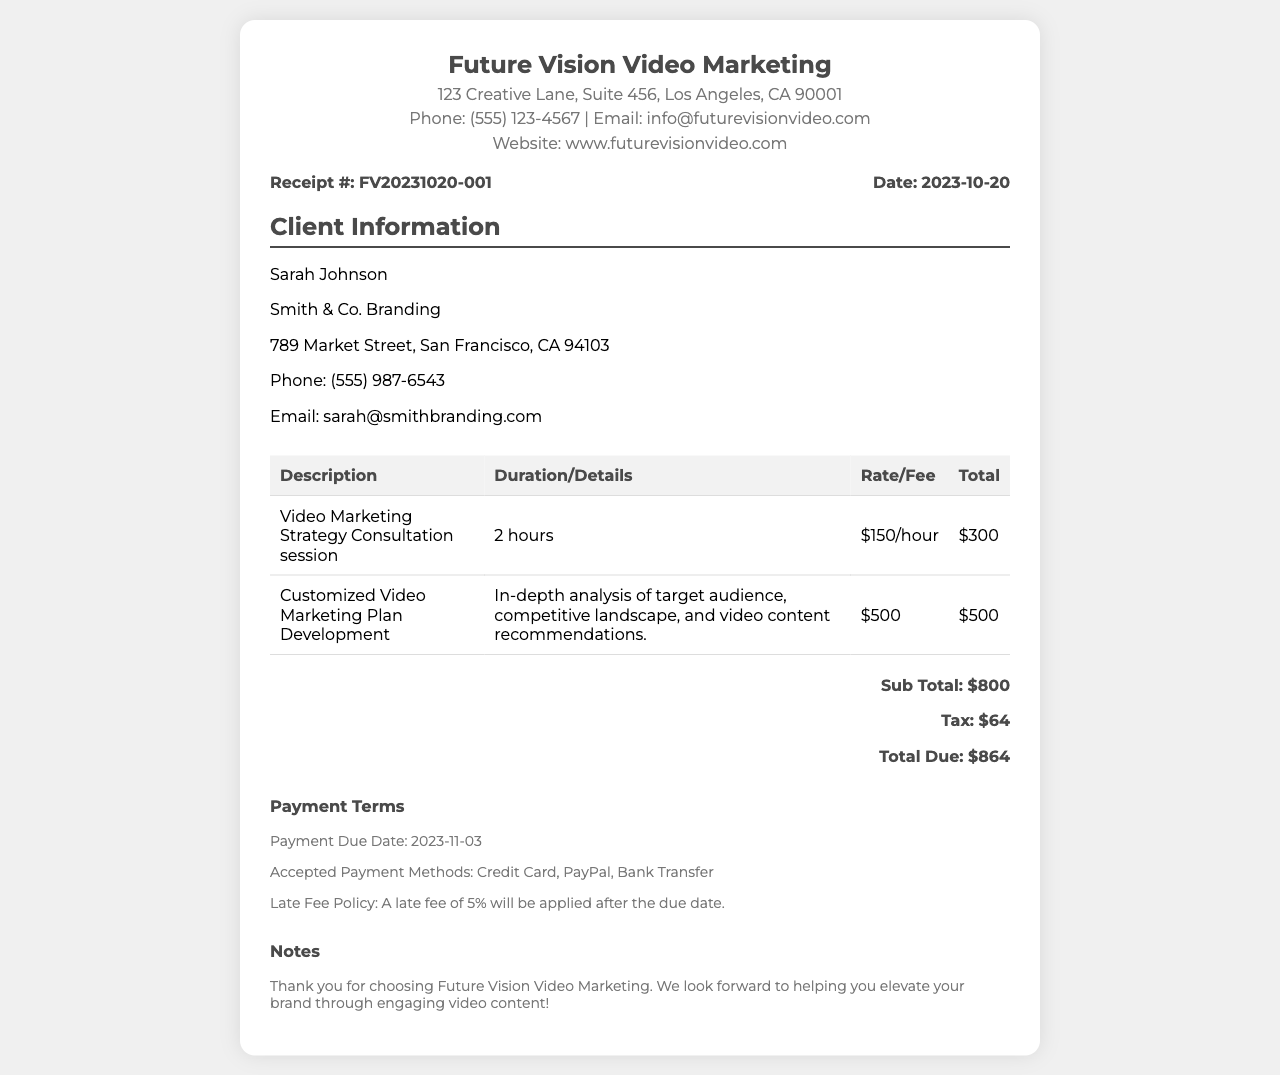What is the receipt number? The receipt number is provided in the document under the receipt details section.
Answer: FV20231020-001 Who is the client? The client's name is listed in the client information section of the document.
Answer: Sarah Johnson What is the total amount due? The total due is calculated at the end of the receipt in the total section.
Answer: $864 What service was provided for two hours? The document lists the services rendered, one of which includes a duration of two hours.
Answer: Video Marketing Strategy Consultation session What is the payment due date? The payment due date is mentioned in the payment terms section of the receipt.
Answer: 2023-11-03 What is included in the customized video marketing plan development? The document specifies details about the service in the services section, which provides further insights.
Answer: In-depth analysis of target audience, competitive landscape, and video content recommendations What tax amount was charged? The tax is explicitly mentioned in the total section of the receipt.
Answer: $64 What late fee percentage applies? The late fee policy specifies the percentage applied after the due date, found in the payment terms.
Answer: 5% 